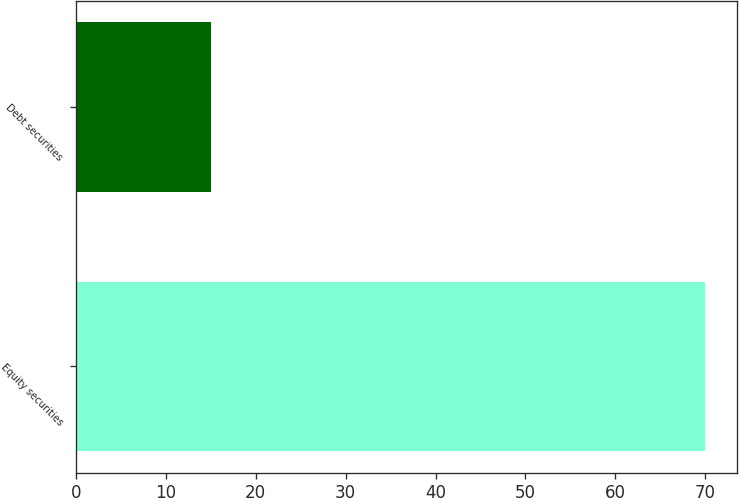Convert chart. <chart><loc_0><loc_0><loc_500><loc_500><bar_chart><fcel>Equity securities<fcel>Debt securities<nl><fcel>70<fcel>15<nl></chart> 